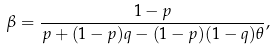Convert formula to latex. <formula><loc_0><loc_0><loc_500><loc_500>\beta = \frac { 1 - p } { p + ( 1 - p ) q - ( 1 - p ) ( 1 - q ) \theta } ,</formula> 